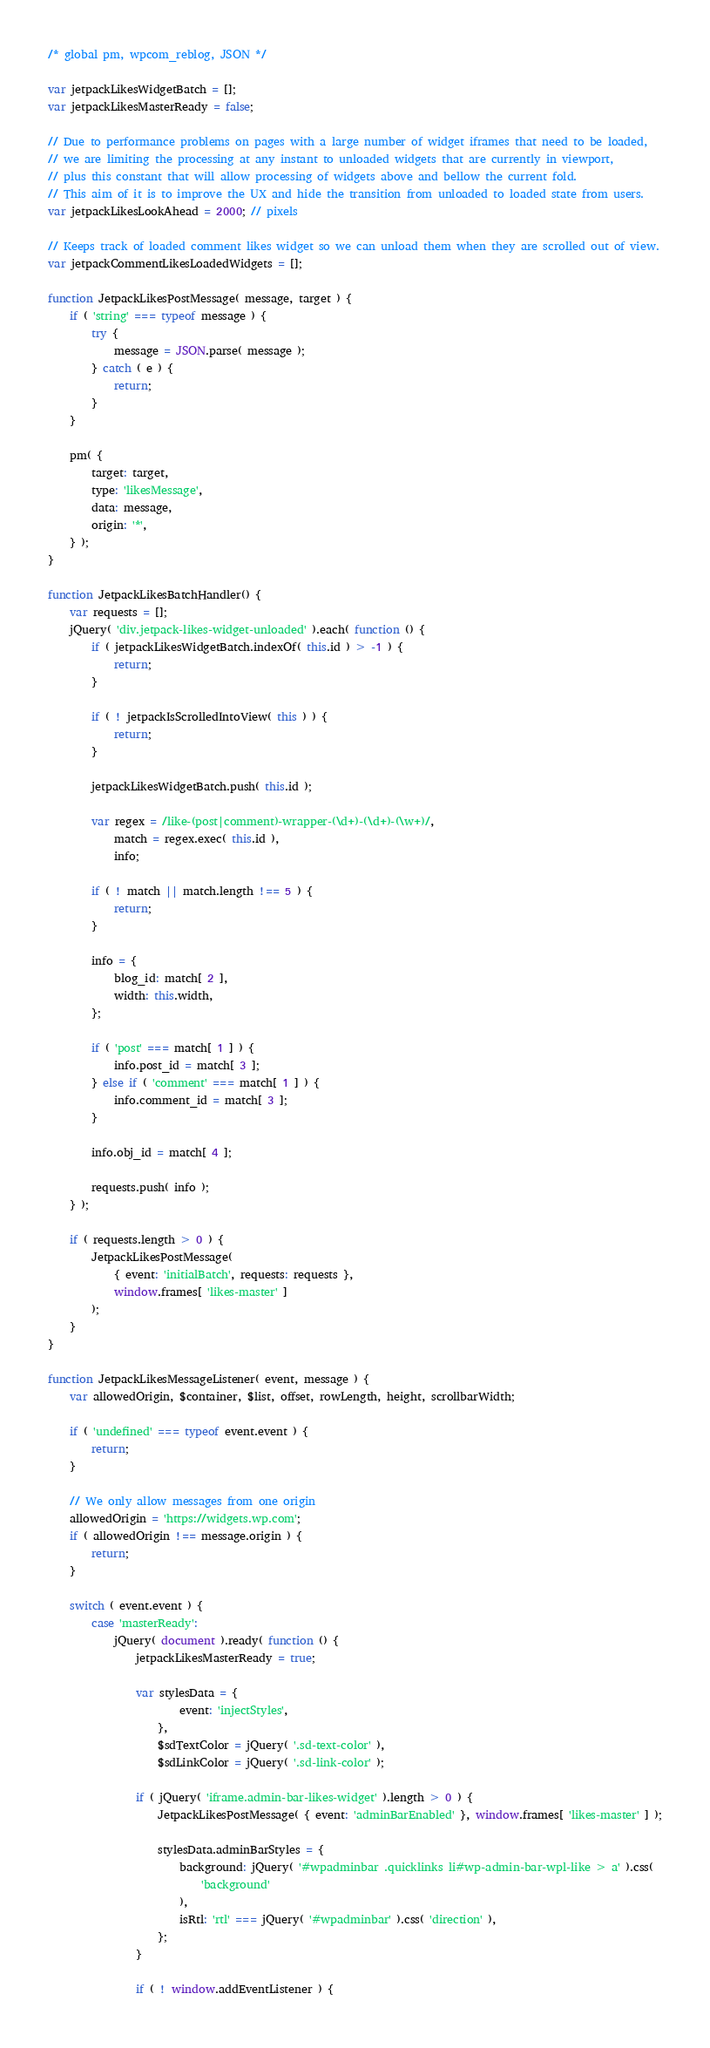<code> <loc_0><loc_0><loc_500><loc_500><_JavaScript_>/* global pm, wpcom_reblog, JSON */

var jetpackLikesWidgetBatch = [];
var jetpackLikesMasterReady = false;

// Due to performance problems on pages with a large number of widget iframes that need to be loaded,
// we are limiting the processing at any instant to unloaded widgets that are currently in viewport,
// plus this constant that will allow processing of widgets above and bellow the current fold.
// This aim of it is to improve the UX and hide the transition from unloaded to loaded state from users.
var jetpackLikesLookAhead = 2000; // pixels

// Keeps track of loaded comment likes widget so we can unload them when they are scrolled out of view.
var jetpackCommentLikesLoadedWidgets = [];

function JetpackLikesPostMessage( message, target ) {
	if ( 'string' === typeof message ) {
		try {
			message = JSON.parse( message );
		} catch ( e ) {
			return;
		}
	}

	pm( {
		target: target,
		type: 'likesMessage',
		data: message,
		origin: '*',
	} );
}

function JetpackLikesBatchHandler() {
	var requests = [];
	jQuery( 'div.jetpack-likes-widget-unloaded' ).each( function () {
		if ( jetpackLikesWidgetBatch.indexOf( this.id ) > -1 ) {
			return;
		}

		if ( ! jetpackIsScrolledIntoView( this ) ) {
			return;
		}

		jetpackLikesWidgetBatch.push( this.id );

		var regex = /like-(post|comment)-wrapper-(\d+)-(\d+)-(\w+)/,
			match = regex.exec( this.id ),
			info;

		if ( ! match || match.length !== 5 ) {
			return;
		}

		info = {
			blog_id: match[ 2 ],
			width: this.width,
		};

		if ( 'post' === match[ 1 ] ) {
			info.post_id = match[ 3 ];
		} else if ( 'comment' === match[ 1 ] ) {
			info.comment_id = match[ 3 ];
		}

		info.obj_id = match[ 4 ];

		requests.push( info );
	} );

	if ( requests.length > 0 ) {
		JetpackLikesPostMessage(
			{ event: 'initialBatch', requests: requests },
			window.frames[ 'likes-master' ]
		);
	}
}

function JetpackLikesMessageListener( event, message ) {
	var allowedOrigin, $container, $list, offset, rowLength, height, scrollbarWidth;

	if ( 'undefined' === typeof event.event ) {
		return;
	}

	// We only allow messages from one origin
	allowedOrigin = 'https://widgets.wp.com';
	if ( allowedOrigin !== message.origin ) {
		return;
	}

	switch ( event.event ) {
		case 'masterReady':
			jQuery( document ).ready( function () {
				jetpackLikesMasterReady = true;

				var stylesData = {
						event: 'injectStyles',
					},
					$sdTextColor = jQuery( '.sd-text-color' ),
					$sdLinkColor = jQuery( '.sd-link-color' );

				if ( jQuery( 'iframe.admin-bar-likes-widget' ).length > 0 ) {
					JetpackLikesPostMessage( { event: 'adminBarEnabled' }, window.frames[ 'likes-master' ] );

					stylesData.adminBarStyles = {
						background: jQuery( '#wpadminbar .quicklinks li#wp-admin-bar-wpl-like > a' ).css(
							'background'
						),
						isRtl: 'rtl' === jQuery( '#wpadminbar' ).css( 'direction' ),
					};
				}

				if ( ! window.addEventListener ) {</code> 